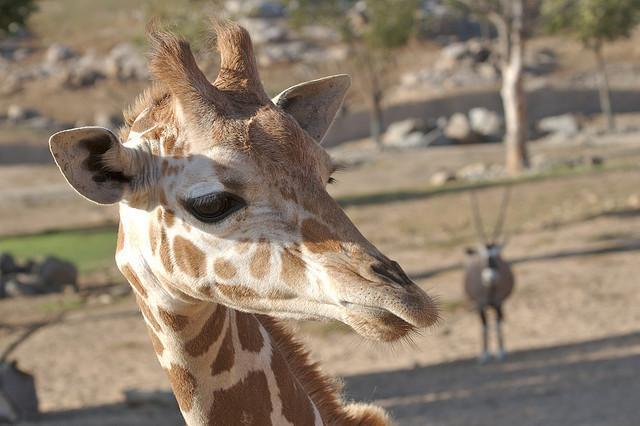How many horns does the animal in the background have?
Give a very brief answer. 2. 